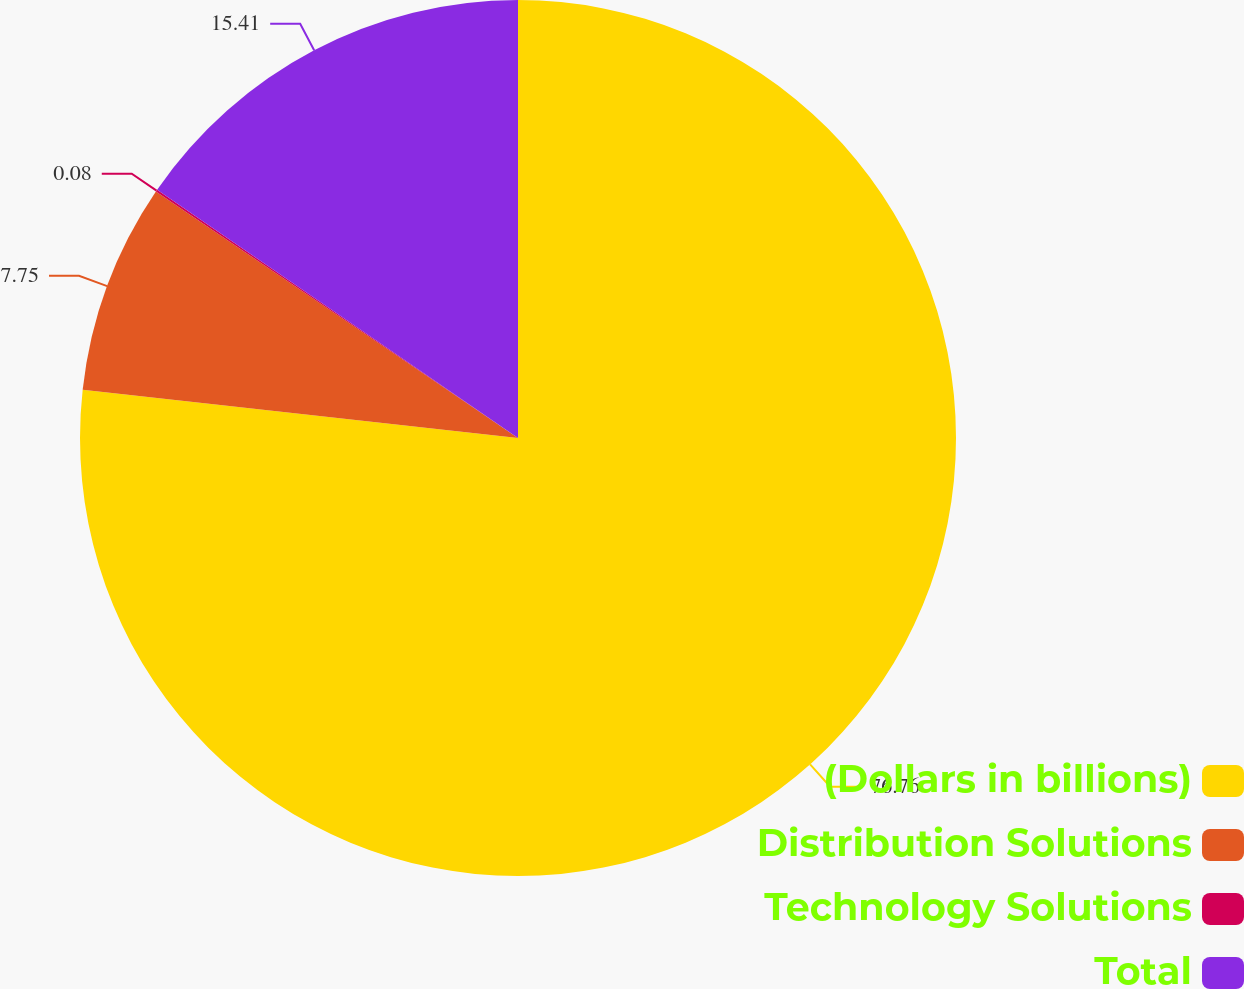<chart> <loc_0><loc_0><loc_500><loc_500><pie_chart><fcel>(Dollars in billions)<fcel>Distribution Solutions<fcel>Technology Solutions<fcel>Total<nl><fcel>76.76%<fcel>7.75%<fcel>0.08%<fcel>15.41%<nl></chart> 